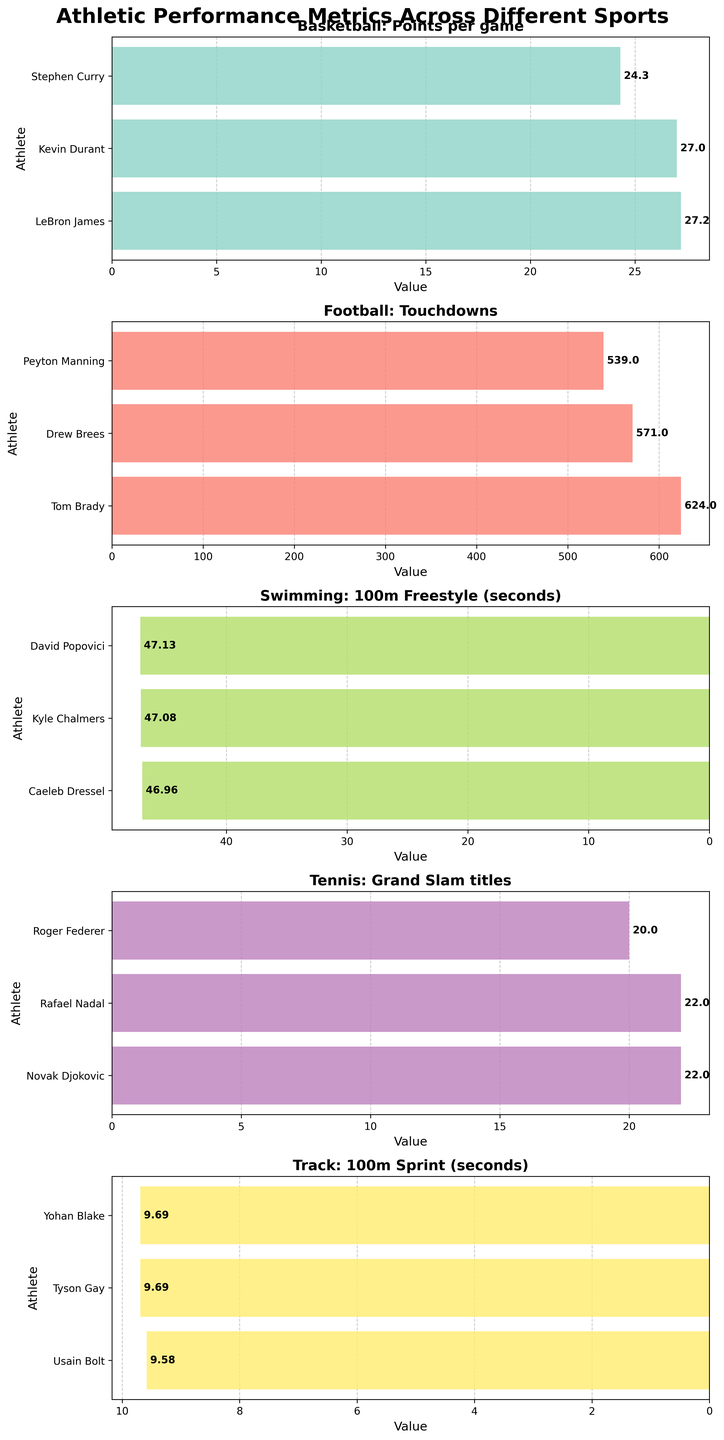Which athlete has the highest Points per game in Basketball? Look at the subplot for Basketball and identify the athlete with the highest bar in the Points per game category.
Answer: LeBron James Which sport has the least number of athletes shown in the figure? Look at each subplot and count the number of athletes in each sport. The sport with the least bars represents the least number of athletes.
Answer: Track How many more Grand Slam titles does Novak Djokovic have compared to Roger Federer? Compare the Grand Slam titles of Novak Djokovic and Roger Federer in the Tennis subplot. Djokovic has 22 titles, while Federer has 20. The difference is 22 - 20.
Answer: 2 Who holds the record for the fastest 100m Sprint time? Look at the Track subplot and identify the athlete with the lowest value (fastest time) which is represented by the largest negative bar on the x-axis.
Answer: Usain Bolt In the Football subplot, how many more touchdowns does Tom Brady have than Peyton Manning? Compare the number of touchdowns for Tom Brady and Peyton Manning. Brady has 624 and Manning has 539. The difference is 624 - 539.
Answer: 85 Which sport has the highest values on the x-axis scale in its subplot? Observe the x-axis scales of all subplots and identify the one with the largest numeric values.
Answer: Football What is the combined number of Grand Slam titles for Rafael Nadal and Novak Djokovic? Add the number of Grand Slam titles for Rafael Nadal and Novak Djokovic from the Tennis subplot. Nadal has 22 and Djokovic has 22. The sum is 22 + 22.
Answer: 44 Which athlete has the closest performance to Caeleb Dressel in the Swimming subplot? Look at the Swimming subplot and compare values to Caeleb Dressel’s value. Identify the athlete whose value is visually closest to 46.96 seconds.
Answer: Kyle Chalmers In the Basketball subplot, which athlete has the lowest Points per game? Identify the athlete with the smallest bar indicating the number of points per game in the Basketball subplot.
Answer: Stephen Curry Which sport has the most balanced performance metrics among the top 3 athletes? Examine the differences among the top performers' values in each subplot. Balance is indicated by smaller differences among these values.
Answer: Track 